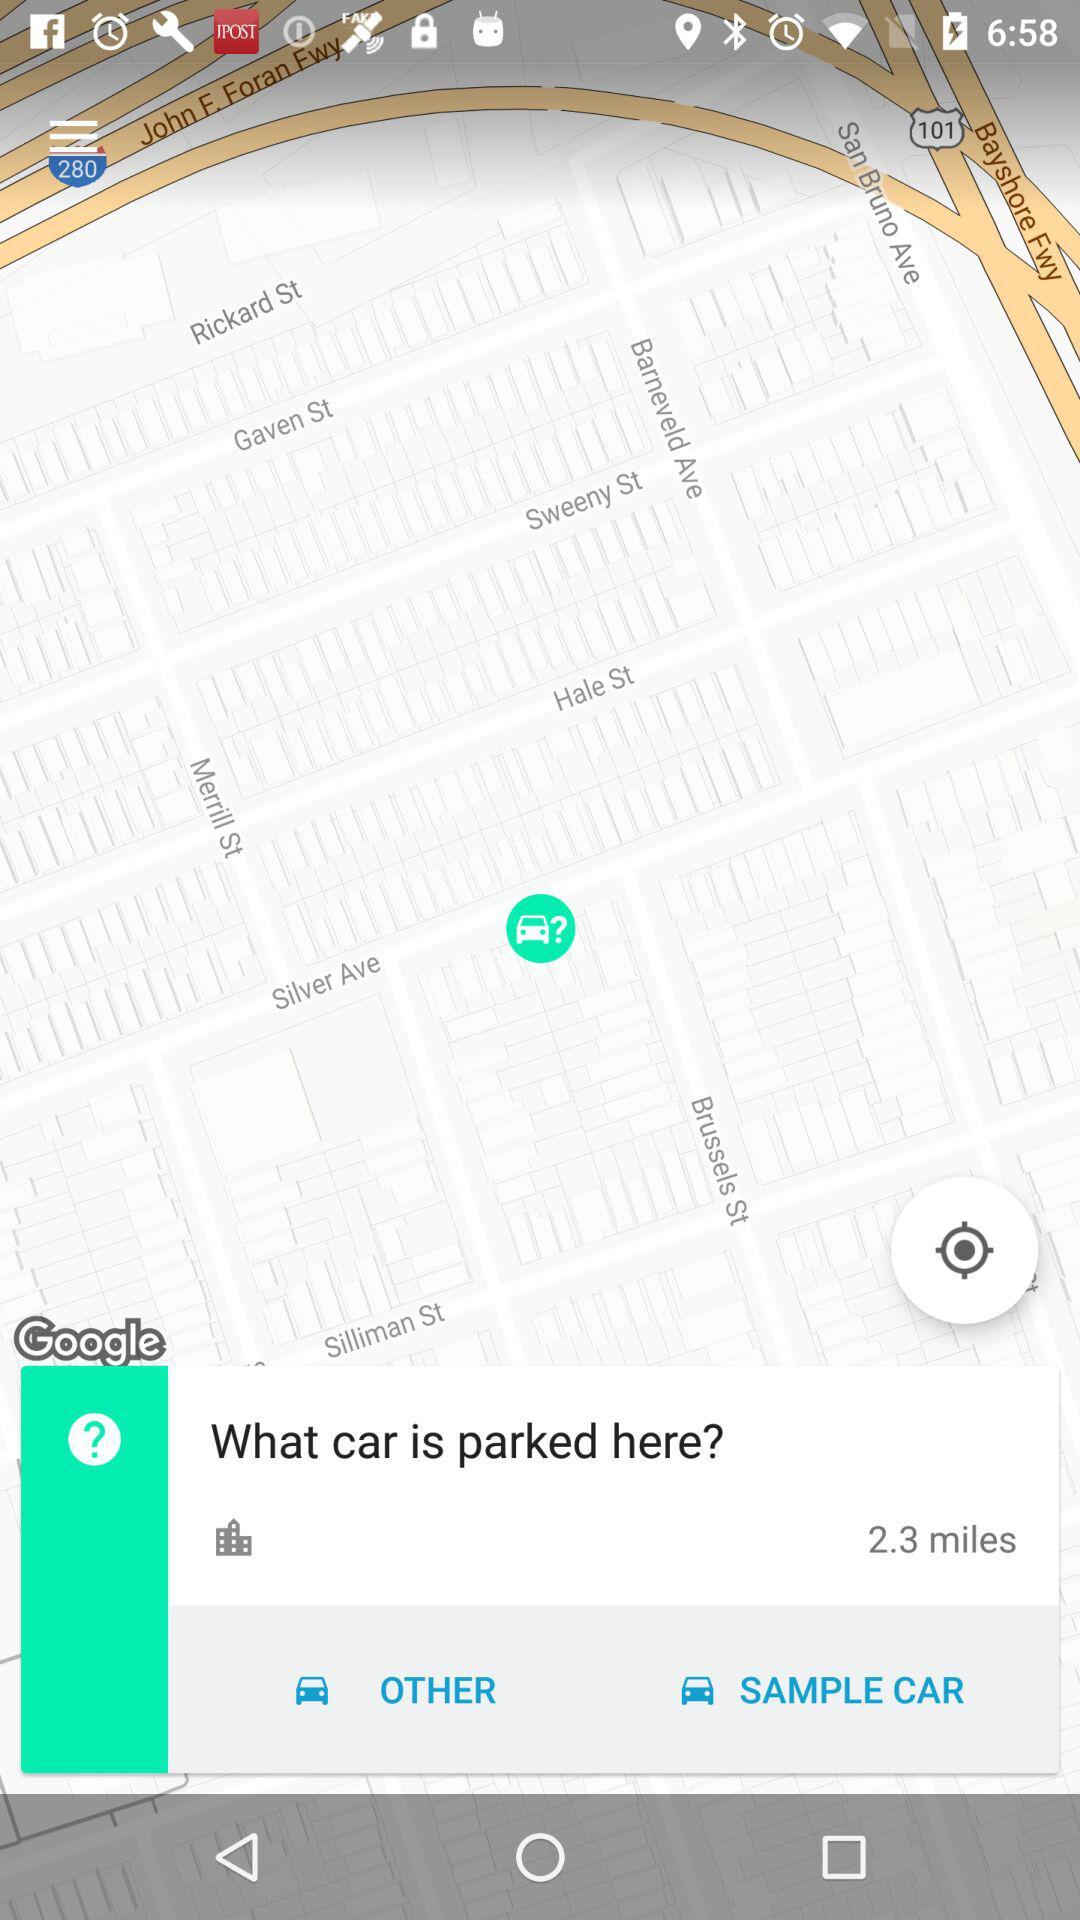What is the given distance? The given distance is 2.3 miles. 